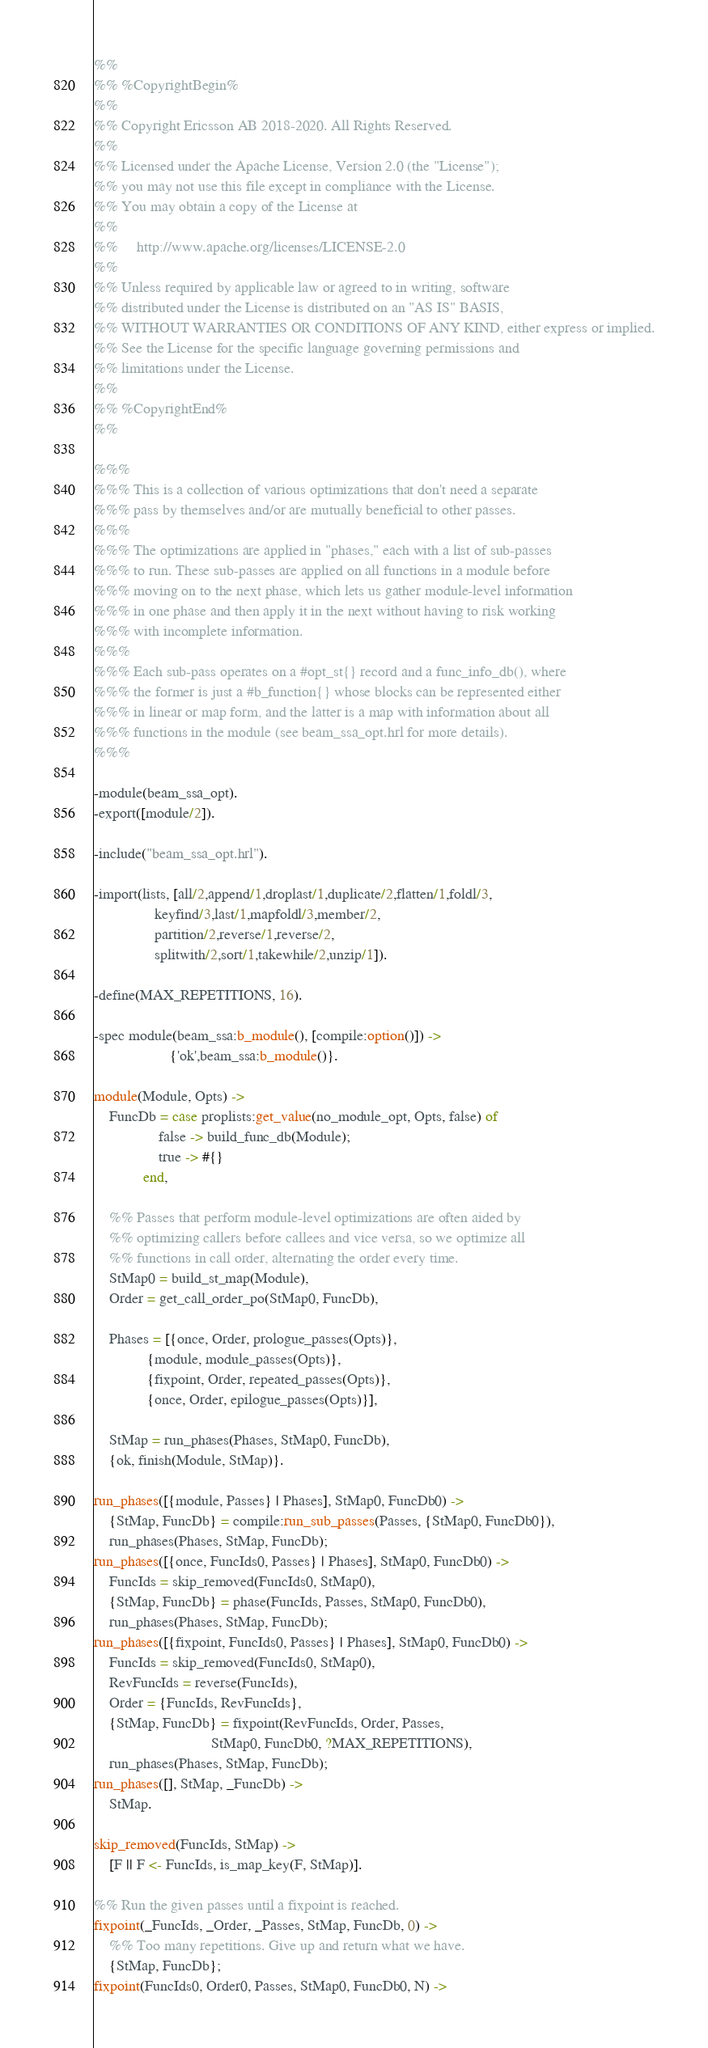<code> <loc_0><loc_0><loc_500><loc_500><_Erlang_>%%
%% %CopyrightBegin%
%%
%% Copyright Ericsson AB 2018-2020. All Rights Reserved.
%%
%% Licensed under the Apache License, Version 2.0 (the "License");
%% you may not use this file except in compliance with the License.
%% You may obtain a copy of the License at
%%
%%     http://www.apache.org/licenses/LICENSE-2.0
%%
%% Unless required by applicable law or agreed to in writing, software
%% distributed under the License is distributed on an "AS IS" BASIS,
%% WITHOUT WARRANTIES OR CONDITIONS OF ANY KIND, either express or implied.
%% See the License for the specific language governing permissions and
%% limitations under the License.
%%
%% %CopyrightEnd%
%%

%%%
%%% This is a collection of various optimizations that don't need a separate
%%% pass by themselves and/or are mutually beneficial to other passes.
%%%
%%% The optimizations are applied in "phases," each with a list of sub-passes
%%% to run. These sub-passes are applied on all functions in a module before
%%% moving on to the next phase, which lets us gather module-level information
%%% in one phase and then apply it in the next without having to risk working
%%% with incomplete information.
%%%
%%% Each sub-pass operates on a #opt_st{} record and a func_info_db(), where
%%% the former is just a #b_function{} whose blocks can be represented either
%%% in linear or map form, and the latter is a map with information about all
%%% functions in the module (see beam_ssa_opt.hrl for more details).
%%%

-module(beam_ssa_opt).
-export([module/2]).

-include("beam_ssa_opt.hrl").

-import(lists, [all/2,append/1,droplast/1,duplicate/2,flatten/1,foldl/3,
                keyfind/3,last/1,mapfoldl/3,member/2,
                partition/2,reverse/1,reverse/2,
                splitwith/2,sort/1,takewhile/2,unzip/1]).

-define(MAX_REPETITIONS, 16).

-spec module(beam_ssa:b_module(), [compile:option()]) ->
                    {'ok',beam_ssa:b_module()}.

module(Module, Opts) ->
    FuncDb = case proplists:get_value(no_module_opt, Opts, false) of
                 false -> build_func_db(Module);
                 true -> #{}
             end,

    %% Passes that perform module-level optimizations are often aided by
    %% optimizing callers before callees and vice versa, so we optimize all
    %% functions in call order, alternating the order every time.
    StMap0 = build_st_map(Module),
    Order = get_call_order_po(StMap0, FuncDb),

    Phases = [{once, Order, prologue_passes(Opts)},
              {module, module_passes(Opts)},
              {fixpoint, Order, repeated_passes(Opts)},
              {once, Order, epilogue_passes(Opts)}],

    StMap = run_phases(Phases, StMap0, FuncDb),
    {ok, finish(Module, StMap)}.

run_phases([{module, Passes} | Phases], StMap0, FuncDb0) ->
    {StMap, FuncDb} = compile:run_sub_passes(Passes, {StMap0, FuncDb0}),
    run_phases(Phases, StMap, FuncDb);
run_phases([{once, FuncIds0, Passes} | Phases], StMap0, FuncDb0) ->
    FuncIds = skip_removed(FuncIds0, StMap0),
    {StMap, FuncDb} = phase(FuncIds, Passes, StMap0, FuncDb0),
    run_phases(Phases, StMap, FuncDb);
run_phases([{fixpoint, FuncIds0, Passes} | Phases], StMap0, FuncDb0) ->
    FuncIds = skip_removed(FuncIds0, StMap0),
    RevFuncIds = reverse(FuncIds),
    Order = {FuncIds, RevFuncIds},
    {StMap, FuncDb} = fixpoint(RevFuncIds, Order, Passes,
                               StMap0, FuncDb0, ?MAX_REPETITIONS),
    run_phases(Phases, StMap, FuncDb);
run_phases([], StMap, _FuncDb) ->
    StMap.

skip_removed(FuncIds, StMap) ->
    [F || F <- FuncIds, is_map_key(F, StMap)].

%% Run the given passes until a fixpoint is reached.
fixpoint(_FuncIds, _Order, _Passes, StMap, FuncDb, 0) ->
    %% Too many repetitions. Give up and return what we have.
    {StMap, FuncDb};
fixpoint(FuncIds0, Order0, Passes, StMap0, FuncDb0, N) -></code> 